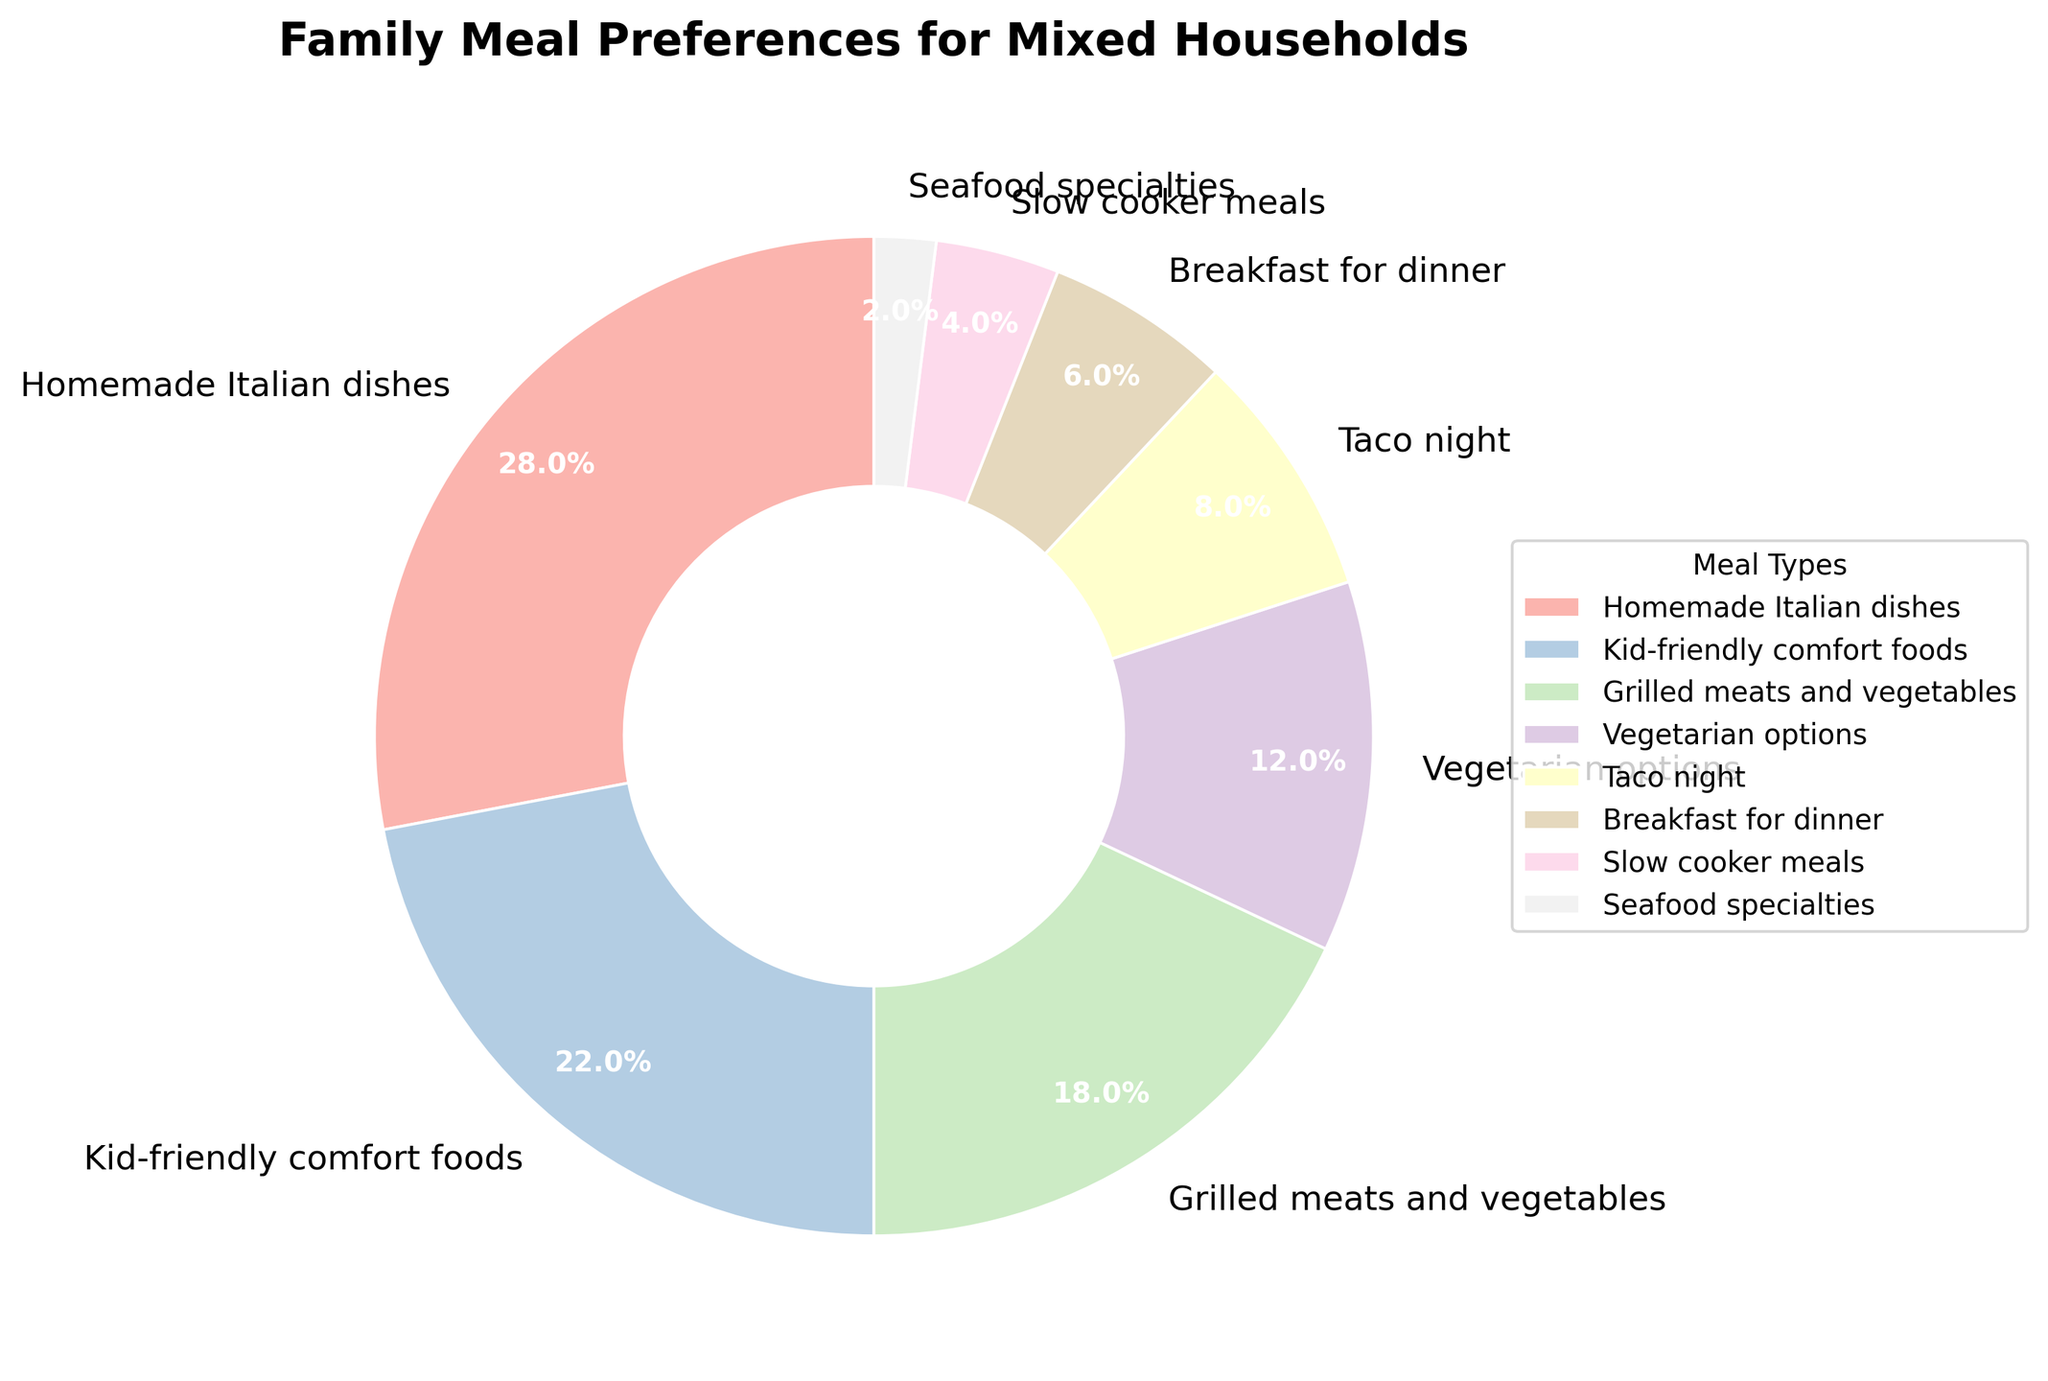What meal preference is the most popular among mixed households as shown in the pie chart? By glancing at the pie chart, we see the section labeled "Homemade Italian dishes" is the largest slice.
Answer: Homemade Italian dishes Which meal preference has nearly double the percentage of "Taco night"? "Taco night" accounts for 8%. "Kid-friendly comfort foods" has 22%, which is more than double 8%.
Answer: Kid-friendly comfort foods Combine the percentages of "Grilled meats and vegetables" and "Vegetarian options". What is the total? The percentages for "Grilled meats and vegetables" and "Vegetarian options" are 18% and 12% respectively. Adding these gives 18 + 12 = 30%.
Answer: 30% Is "Breakfast for dinner" more popular than "Slow cooker meals"? By comparing the percentages, "Breakfast for dinner" is 6% and "Slow cooker meals" is 4%. Thus, "Breakfast for dinner" is more popular.
Answer: Yes Compared to "Seafood specialties", how many times higher is the percentage of "Grilled meats and vegetables"? "Seafood specialties" has 2%, and "Grilled meats and vegetables" has 18%. 18 ÷ 2 = 9, so it's 9 times higher.
Answer: 9 times higher If we group "Kid-friendly comfort foods" and "Homemade Italian dishes" together, what percentage do they represent of the whole pie chart? "Kid-friendly comfort foods" is 22% and "Homemade Italian dishes" is 28%. Adding these gives 22 + 28 = 50%.
Answer: 50% Between "Vegetarian options" and "Taco night", which one is less preferred and by what percentage difference? "Vegetarian options" is 12% and "Taco night" is 8%. The difference is 12 - 8 = 4%.
Answer: Taco night by 4% What is the combined total percentage of the least preferred meal preferences ("Seafood specialties" and "Slow cooker meals")? "Seafood specialties" is 2% and "Slow cooker meals" is 4%. Therefore, 2 + 4 = 6%.
Answer: 6% Which meal preferences have a percentage lower than 10%? By viewing the pie chart, the meals with lower than 10% are "Taco night" (8%), "Breakfast for dinner" (6%), "Slow cooker meals" (4%), and "Seafood specialties" (2%).
Answer: Taco night, Breakfast for dinner, Slow cooker meals, Seafood specialties 